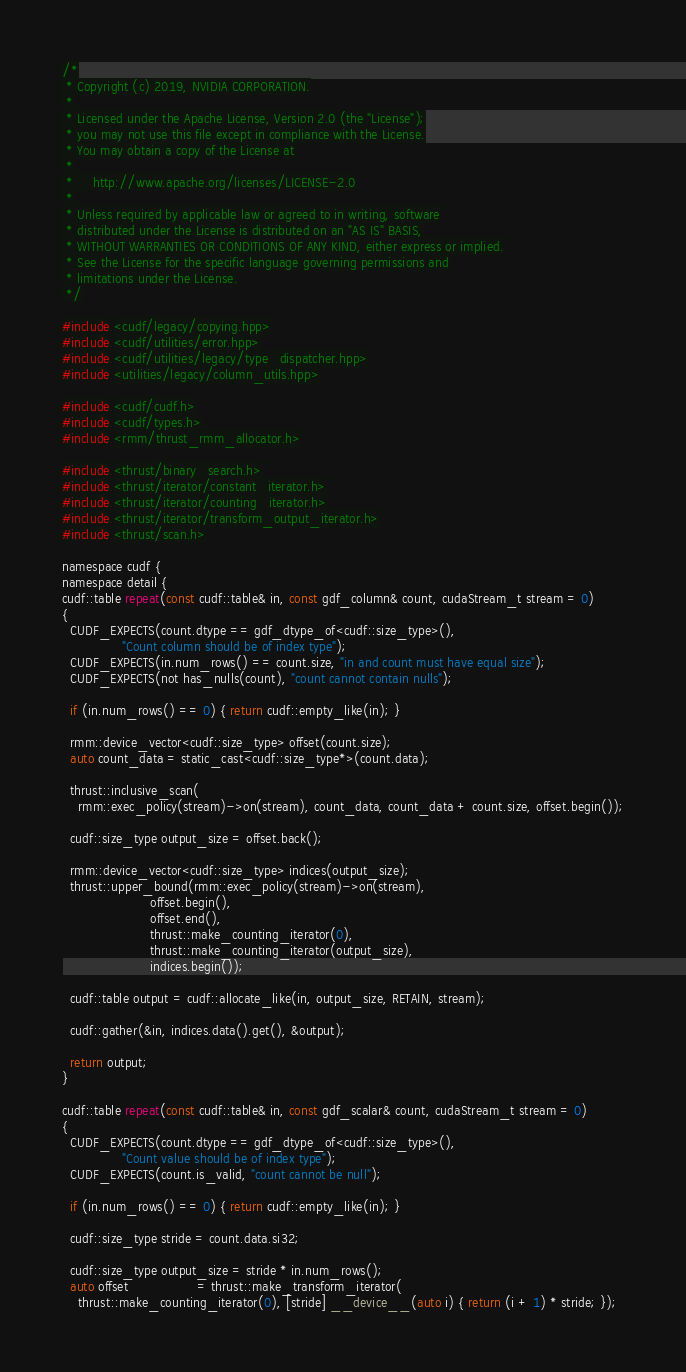<code> <loc_0><loc_0><loc_500><loc_500><_Cuda_>/*
 * Copyright (c) 2019, NVIDIA CORPORATION.
 *
 * Licensed under the Apache License, Version 2.0 (the "License");
 * you may not use this file except in compliance with the License.
 * You may obtain a copy of the License at
 *
 *     http://www.apache.org/licenses/LICENSE-2.0
 *
 * Unless required by applicable law or agreed to in writing, software
 * distributed under the License is distributed on an "AS IS" BASIS,
 * WITHOUT WARRANTIES OR CONDITIONS OF ANY KIND, either express or implied.
 * See the License for the specific language governing permissions and
 * limitations under the License.
 */

#include <cudf/legacy/copying.hpp>
#include <cudf/utilities/error.hpp>
#include <cudf/utilities/legacy/type_dispatcher.hpp>
#include <utilities/legacy/column_utils.hpp>

#include <cudf/cudf.h>
#include <cudf/types.h>
#include <rmm/thrust_rmm_allocator.h>

#include <thrust/binary_search.h>
#include <thrust/iterator/constant_iterator.h>
#include <thrust/iterator/counting_iterator.h>
#include <thrust/iterator/transform_output_iterator.h>
#include <thrust/scan.h>

namespace cudf {
namespace detail {
cudf::table repeat(const cudf::table& in, const gdf_column& count, cudaStream_t stream = 0)
{
  CUDF_EXPECTS(count.dtype == gdf_dtype_of<cudf::size_type>(),
               "Count column should be of index type");
  CUDF_EXPECTS(in.num_rows() == count.size, "in and count must have equal size");
  CUDF_EXPECTS(not has_nulls(count), "count cannot contain nulls");

  if (in.num_rows() == 0) { return cudf::empty_like(in); }

  rmm::device_vector<cudf::size_type> offset(count.size);
  auto count_data = static_cast<cudf::size_type*>(count.data);

  thrust::inclusive_scan(
    rmm::exec_policy(stream)->on(stream), count_data, count_data + count.size, offset.begin());

  cudf::size_type output_size = offset.back();

  rmm::device_vector<cudf::size_type> indices(output_size);
  thrust::upper_bound(rmm::exec_policy(stream)->on(stream),
                      offset.begin(),
                      offset.end(),
                      thrust::make_counting_iterator(0),
                      thrust::make_counting_iterator(output_size),
                      indices.begin());

  cudf::table output = cudf::allocate_like(in, output_size, RETAIN, stream);

  cudf::gather(&in, indices.data().get(), &output);

  return output;
}

cudf::table repeat(const cudf::table& in, const gdf_scalar& count, cudaStream_t stream = 0)
{
  CUDF_EXPECTS(count.dtype == gdf_dtype_of<cudf::size_type>(),
               "Count value should be of index type");
  CUDF_EXPECTS(count.is_valid, "count cannot be null");

  if (in.num_rows() == 0) { return cudf::empty_like(in); }

  cudf::size_type stride = count.data.si32;

  cudf::size_type output_size = stride * in.num_rows();
  auto offset                 = thrust::make_transform_iterator(
    thrust::make_counting_iterator(0), [stride] __device__(auto i) { return (i + 1) * stride; });
</code> 